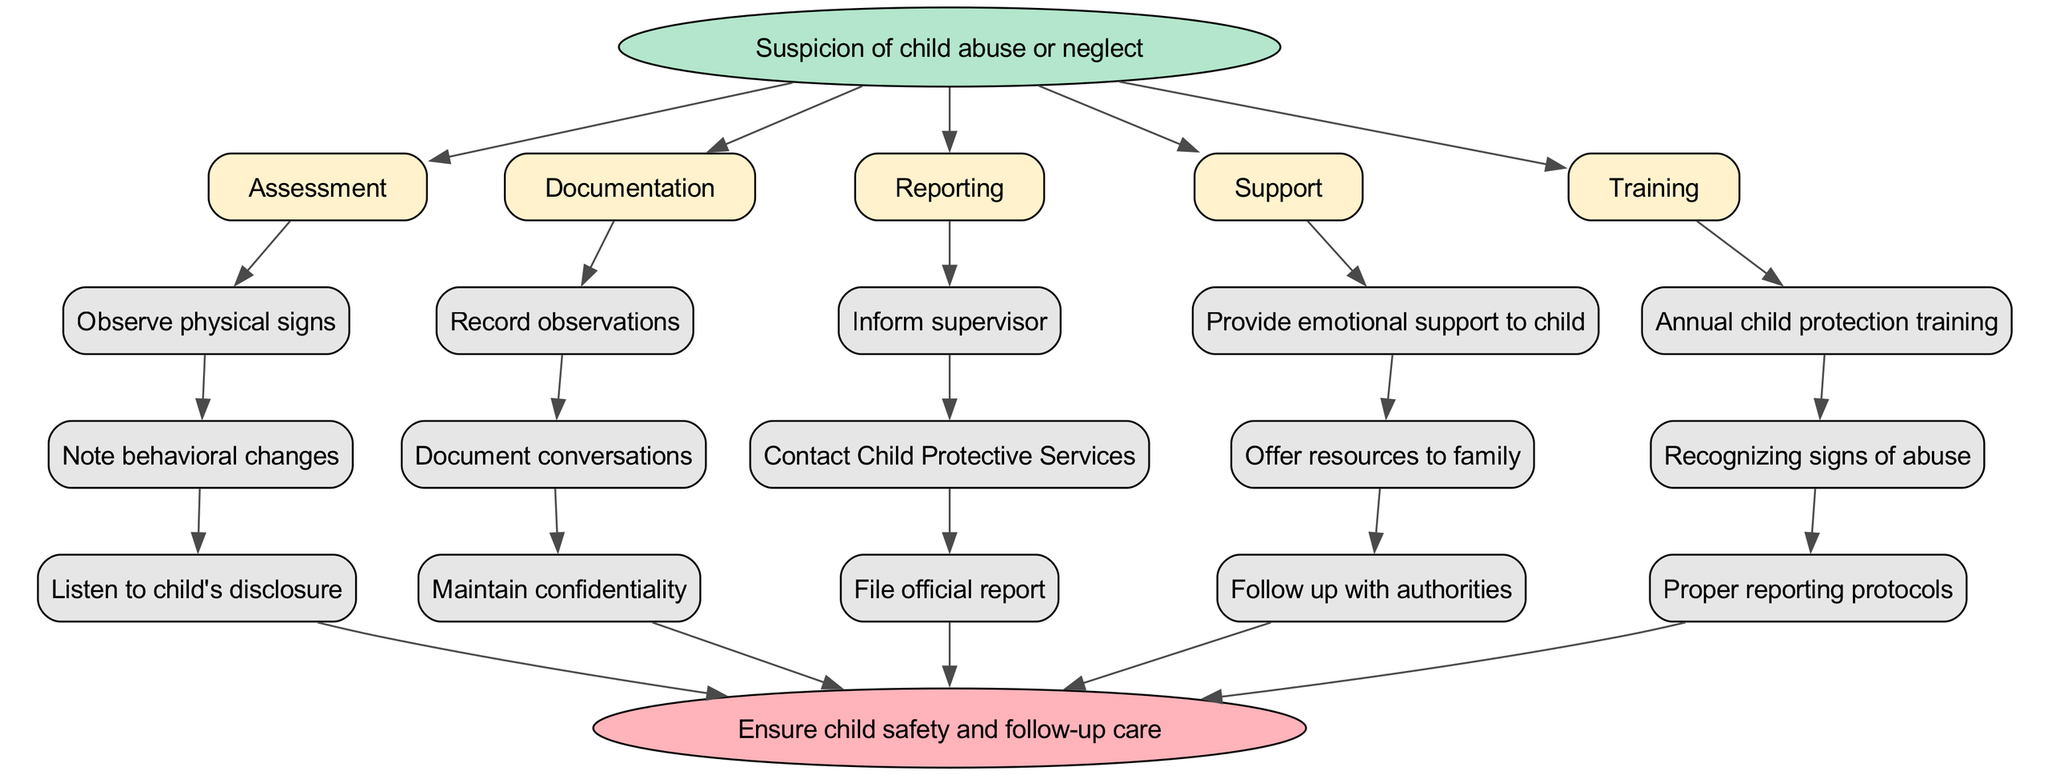What is the starting point of the clinical pathway? The starting point is indicated in the diagram as the first element connected to the initial node. It states "Suspicion of child abuse or neglect."
Answer: Suspicion of child abuse or neglect How many assessment steps are listed in the pathway? By counting the nodes linked to the "Assessment" step, there are three substeps that represent different assessment techniques.
Answer: 3 What should be done first in the documentation process? The first node under the "Documentation" step states "Record observations," which is the initial action to take.
Answer: Record observations Which procedure follows after documenting the observations? The arrow from the "Documentation" step leads to the "Reporting" step, indicating that after documenting, the next action is to report the findings.
Answer: Reporting What type of training is required annually? Within the training section of the diagram, one of the listed requirements is "Annual child protection training," signifying an essential training element.
Answer: Annual child protection training Which reporting action is taken after informing a supervisor? The next node specified after "Inform supervisor" in the reporting process is "Contact Child Protective Services," indicating the subsequent action.
Answer: Contact Child Protective Services What is the endpoint of the clinical pathway? The endpoint is illustrated at the last node in the diagram, clearly stating the final objective is to "Ensure child safety and follow-up care."
Answer: Ensure child safety and follow-up care What support action is provided to the child? Reading the support actions, it shows that "Provide emotional support to child" is one of the critical actions taken towards the child involved.
Answer: Provide emotional support to child How do the assessment and documentation steps relate to each other? The diagram connects the "Assessment" step directly to the "Documentation" step, illustrating that assessment precedes documentation in the process.
Answer: Assessment leads to Documentation 